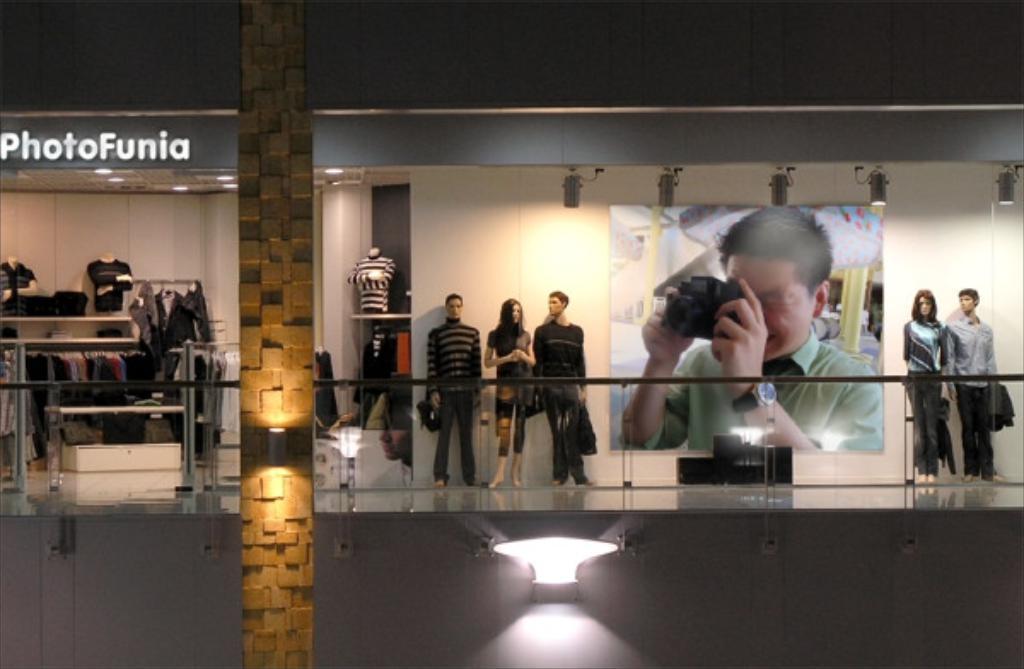How would you summarize this image in a sentence or two? It looks like the picture is captured inside some mall, there is clothing store and outside that store there are some mannequins and behind the mannequins there is a wall and on the wall there is a poster of a person clicking a photo. 